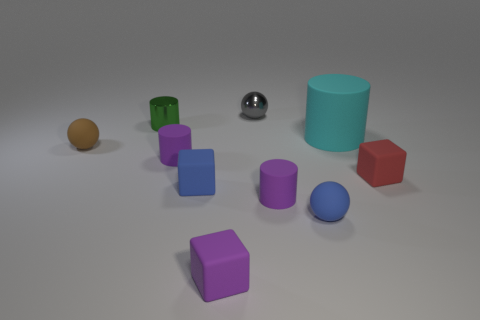Subtract 1 cylinders. How many cylinders are left? 3 Subtract all red spheres. Subtract all purple cubes. How many spheres are left? 3 Subtract all gray metal objects. Subtract all large yellow things. How many objects are left? 9 Add 1 gray metallic things. How many gray metallic things are left? 2 Add 2 large cyan matte cylinders. How many large cyan matte cylinders exist? 3 Subtract 0 green balls. How many objects are left? 10 Subtract all spheres. How many objects are left? 7 